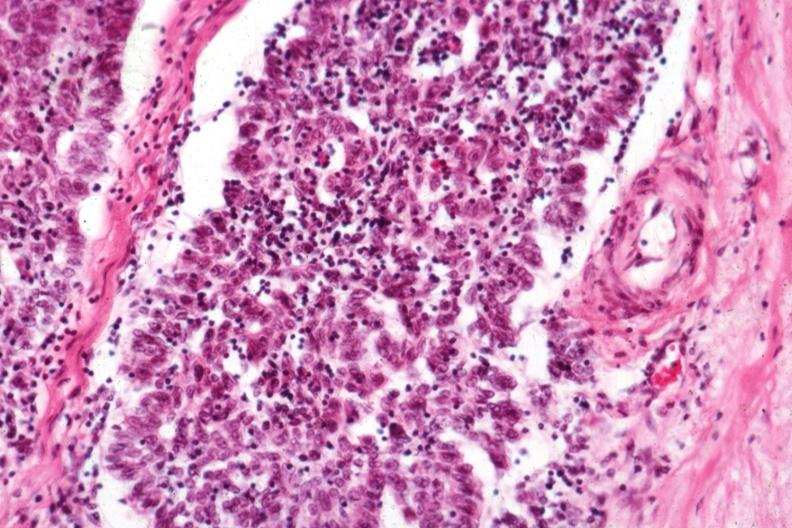does maxillary sinus show predominant epithelial component?
Answer the question using a single word or phrase. No 